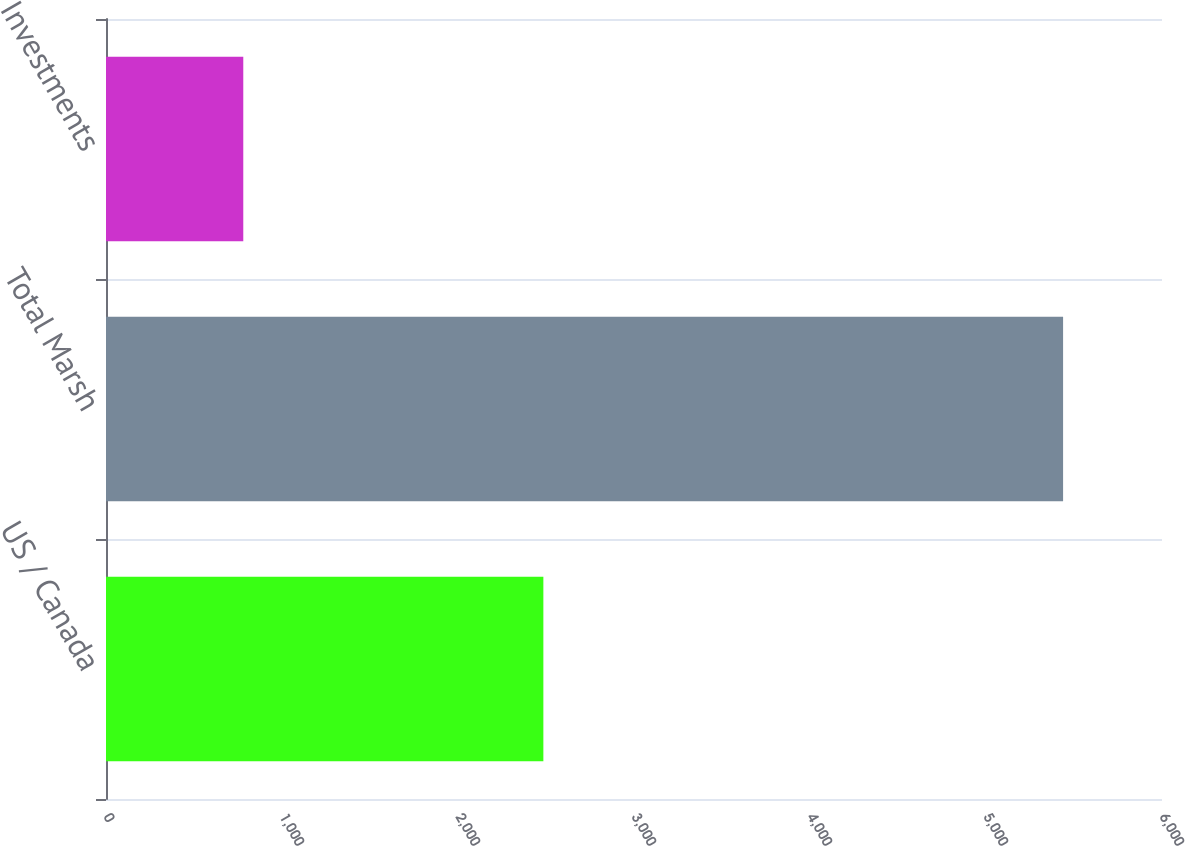Convert chart. <chart><loc_0><loc_0><loc_500><loc_500><bar_chart><fcel>US / Canada<fcel>Total Marsh<fcel>Investments<nl><fcel>2485<fcel>5438<fcel>780<nl></chart> 